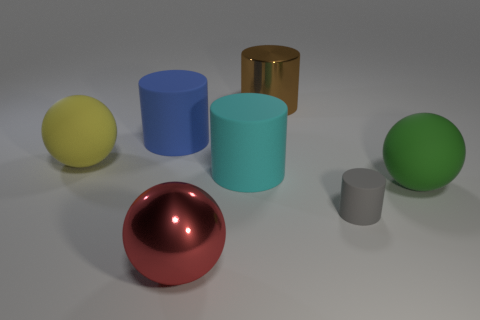Is there any other thing that is the same size as the gray thing?
Your answer should be compact. No. Is the material of the blue object behind the large green sphere the same as the big object that is on the right side of the tiny rubber cylinder?
Provide a succinct answer. Yes. What material is the blue cylinder that is behind the matte sphere that is right of the yellow rubber ball?
Give a very brief answer. Rubber. What material is the large sphere to the left of the large red shiny sphere?
Ensure brevity in your answer.  Rubber. How many other matte objects have the same shape as the brown thing?
Your answer should be compact. 3. Is the tiny cylinder the same color as the shiny sphere?
Your response must be concise. No. There is a large cylinder in front of the big ball that is on the left side of the big red metal object that is on the left side of the big brown metal cylinder; what is it made of?
Your answer should be compact. Rubber. Are there any yellow spheres to the right of the green rubber ball?
Your answer should be very brief. No. The yellow rubber object that is the same size as the green thing is what shape?
Keep it short and to the point. Sphere. Do the small gray cylinder and the red object have the same material?
Make the answer very short. No. 